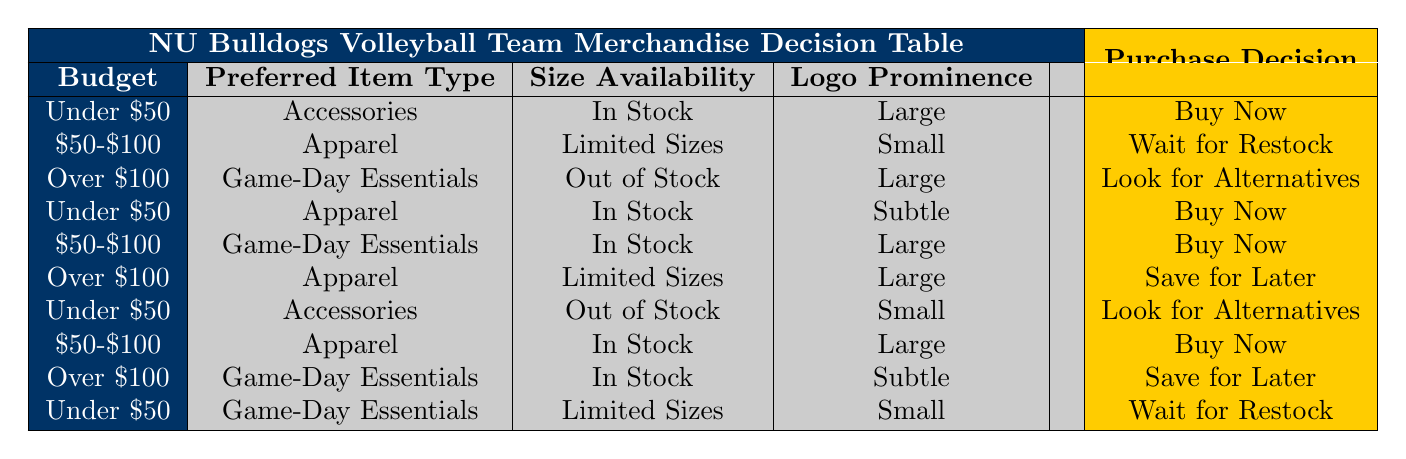What is the purchase decision for accessories under $50 with a large logo? According to the table, if the budget is under $50, the preferred item type is accessories, and there's large logo prominence, the purchase decision is to "Buy Now."
Answer: Buy Now What action should be taken for game-day essentials priced over $100 and out of stock? The table shows that for over $100, if game-day essentials are out of stock, the action is to "Look for Alternatives."
Answer: Look for Alternatives Is there a buy decision for items priced between $50 and $100? Yes, the table indicates that for apparel and game-day essentials priced between $50 and $100, there are instances where the purchase decision is "Buy Now."
Answer: Yes What is the maximum size availability for "Apparel" listed in the decision table? From the table, "Apparel" appears under both "Limited Sizes" and "In Stock," indicating that there are options available in two sizing conditions, but not all sizes are available; hence, "Limited Sizes" is the maximum noted.
Answer: Limited Sizes For apparel under $50 that is in stock and has a subtle logo, what is the purchase recommendation? The table specifies that for apparel that is under $50, in stock, and has a subtle logo prominence, the action is to "Buy Now."
Answer: Buy Now What are the conditions that lead to saving for later? Reviewing the table shows two scenarios: purchasing apparel over $100 with limited sizes or game-day essentials over $100 that are in stock with subtle logo prominence both lead to the action being "Save for Later."
Answer: Apparel over $100 (Limited Sizes) or Game-Day Essentials over $100 (In Stock, Subtle) Are there any items that require waiting for restock? Yes, the table lists two conditions where waiting for restock is the action: game-day essentials under $50 with limited sizes and apparel between $50 and $100 with limited sizes.
Answer: Yes What item type has the greatest variety in purchase actions? To determine the item type with the most diverse purchase actions, the table must be reviewed. Apparel appears in multiple scenarios across the budget and stock statuses leading to different actions: "Buy Now," "Wait for Restock," and "Save for Later." Thus, apparel has the greatest variety.
Answer: Apparel What is the purchase decision for game-day essentials that are in stock and priced between $50 and $100? According to the table, if game-day essentials are in stock and priced between $50 and $100, the purchase action is to "Buy Now."
Answer: Buy Now 